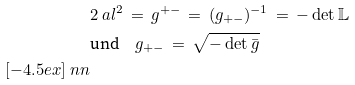<formula> <loc_0><loc_0><loc_500><loc_500>& 2 \ a l ^ { 2 } \, = \, g ^ { + - } \, = \, ( g _ { + - } ) ^ { - 1 } \, = \, - \det \mathbb { L } \\ & \text {und} \quad g _ { + - } \, = \, \sqrt { - \det \bar { g } } \\ [ - 4 . 5 e x ] \ n n</formula> 